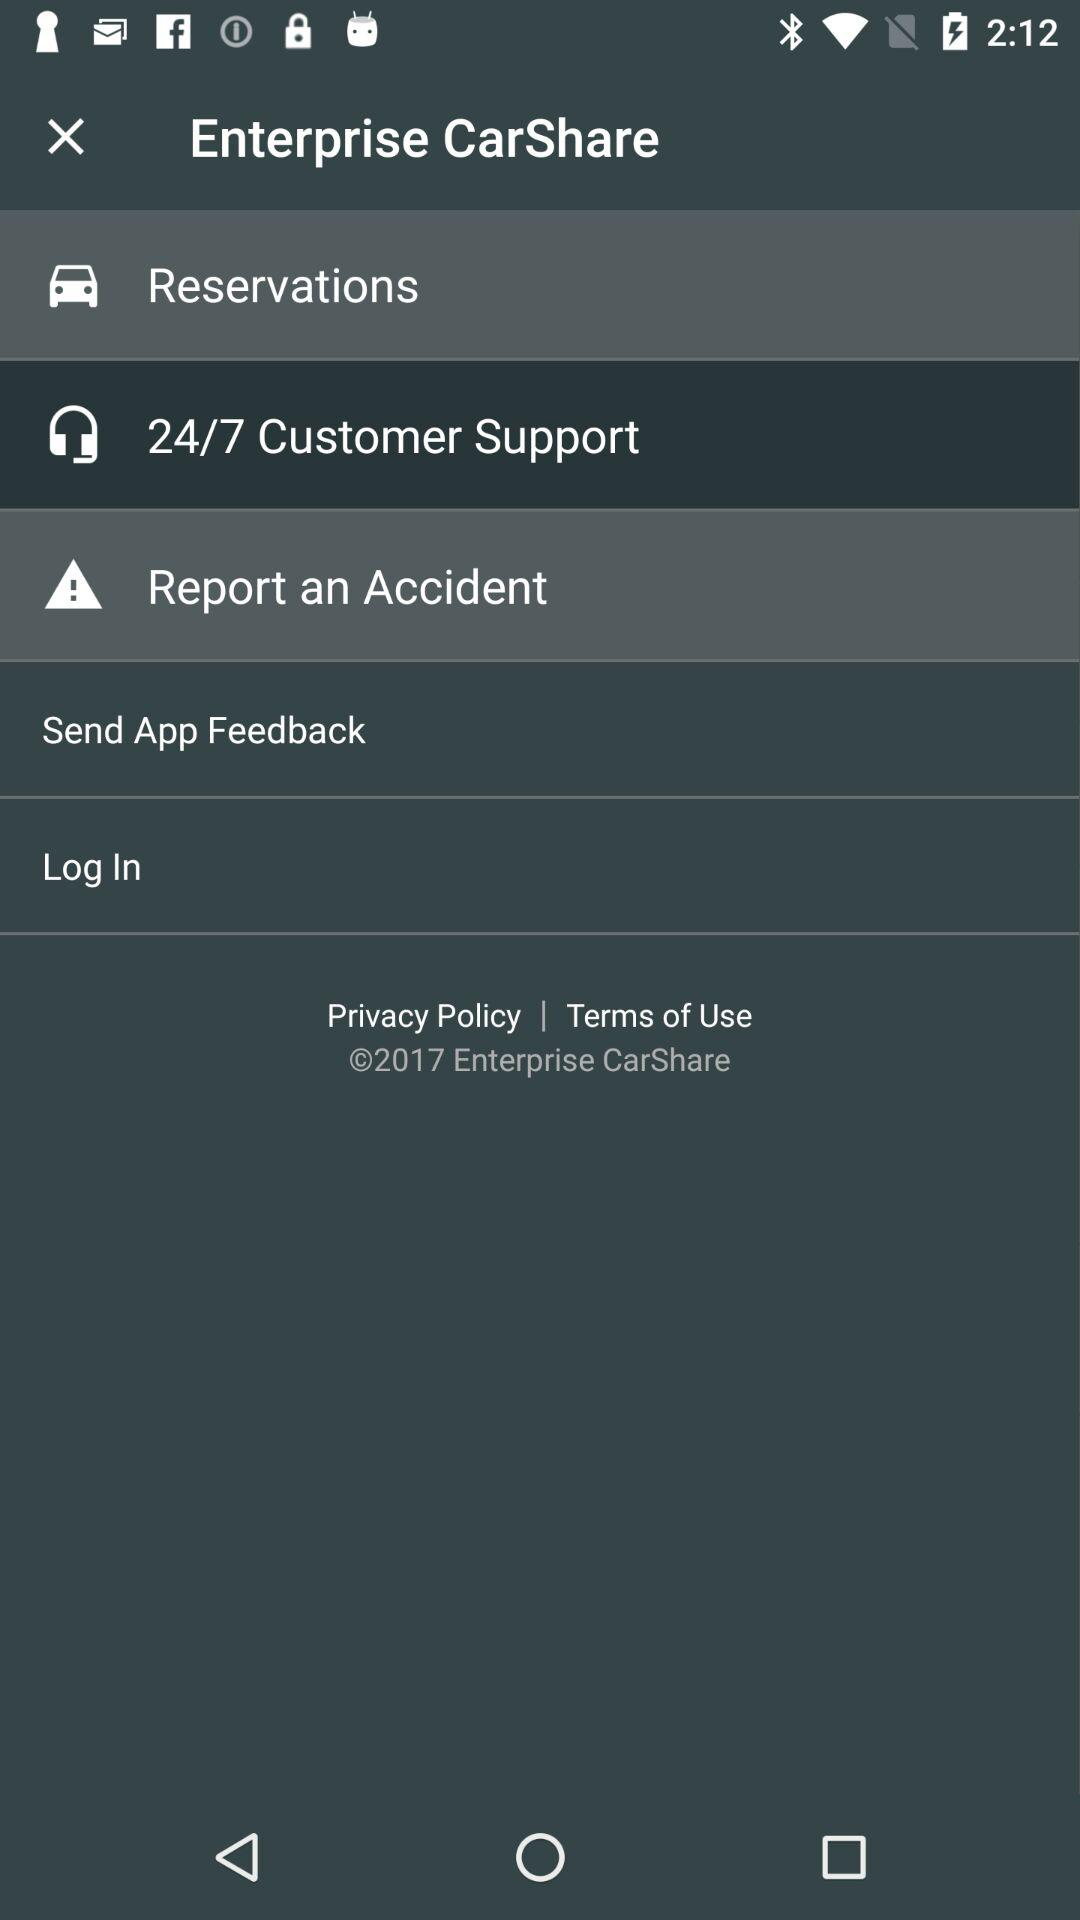What is the application name? The application name is "Enterprise CarShare". 